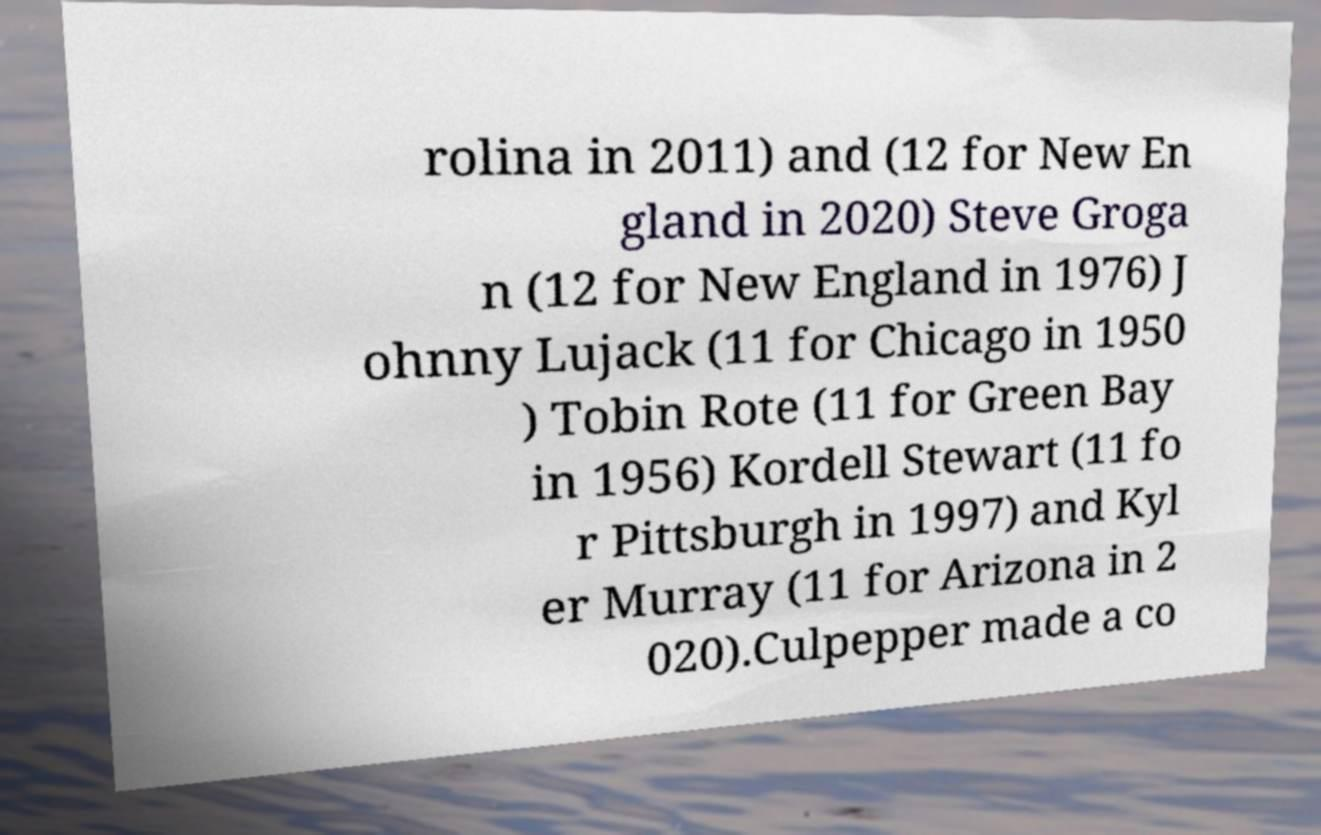What messages or text are displayed in this image? I need them in a readable, typed format. rolina in 2011) and (12 for New En gland in 2020) Steve Groga n (12 for New England in 1976) J ohnny Lujack (11 for Chicago in 1950 ) Tobin Rote (11 for Green Bay in 1956) Kordell Stewart (11 fo r Pittsburgh in 1997) and Kyl er Murray (11 for Arizona in 2 020).Culpepper made a co 